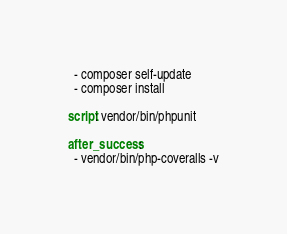Convert code to text. <code><loc_0><loc_0><loc_500><loc_500><_YAML_>  - composer self-update
  - composer install

script: vendor/bin/phpunit

after_success:
  - vendor/bin/php-coveralls -v</code> 